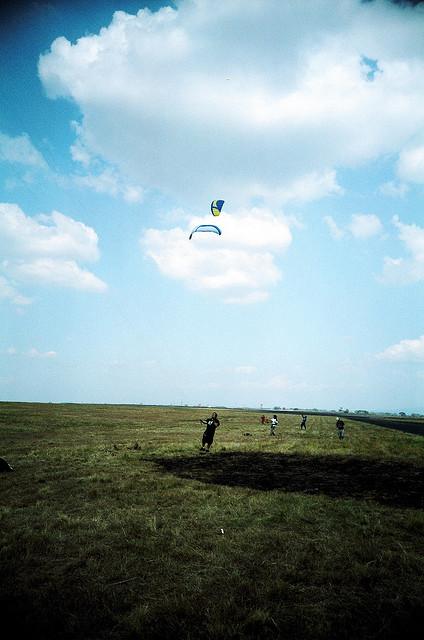Is the scene on a beach?
Be succinct. No. Is this a normal looking photo?
Quick response, please. Yes. What are the people doing on the empty field?
Short answer required. Flying kites. Is this a scene in Kansas?
Write a very short answer. Yes. How many kits are in the air?
Give a very brief answer. 2. Is this a cloudy day?
Answer briefly. No. What is the condition of the grass?
Give a very brief answer. Dry. What are the people doing?
Answer briefly. Flying kites. Where are they?
Short answer required. Field. Is it about to rain?
Keep it brief. No. Can the flyers of the kites be seen?
Give a very brief answer. Yes. What are the people standing on?
Short answer required. Grass. What time of day was this photo taken?
Give a very brief answer. Afternoon. Where is this picture taken?
Keep it brief. Outside. 